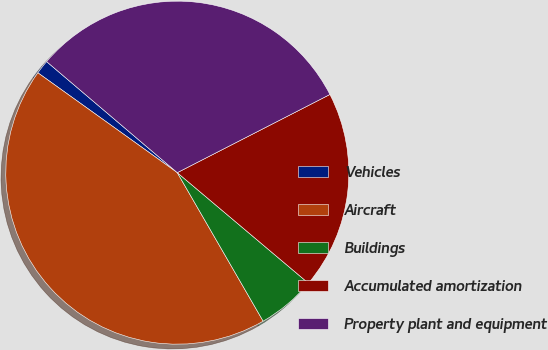<chart> <loc_0><loc_0><loc_500><loc_500><pie_chart><fcel>Vehicles<fcel>Aircraft<fcel>Buildings<fcel>Accumulated amortization<fcel>Property plant and equipment<nl><fcel>1.32%<fcel>43.23%<fcel>5.51%<fcel>18.68%<fcel>31.25%<nl></chart> 